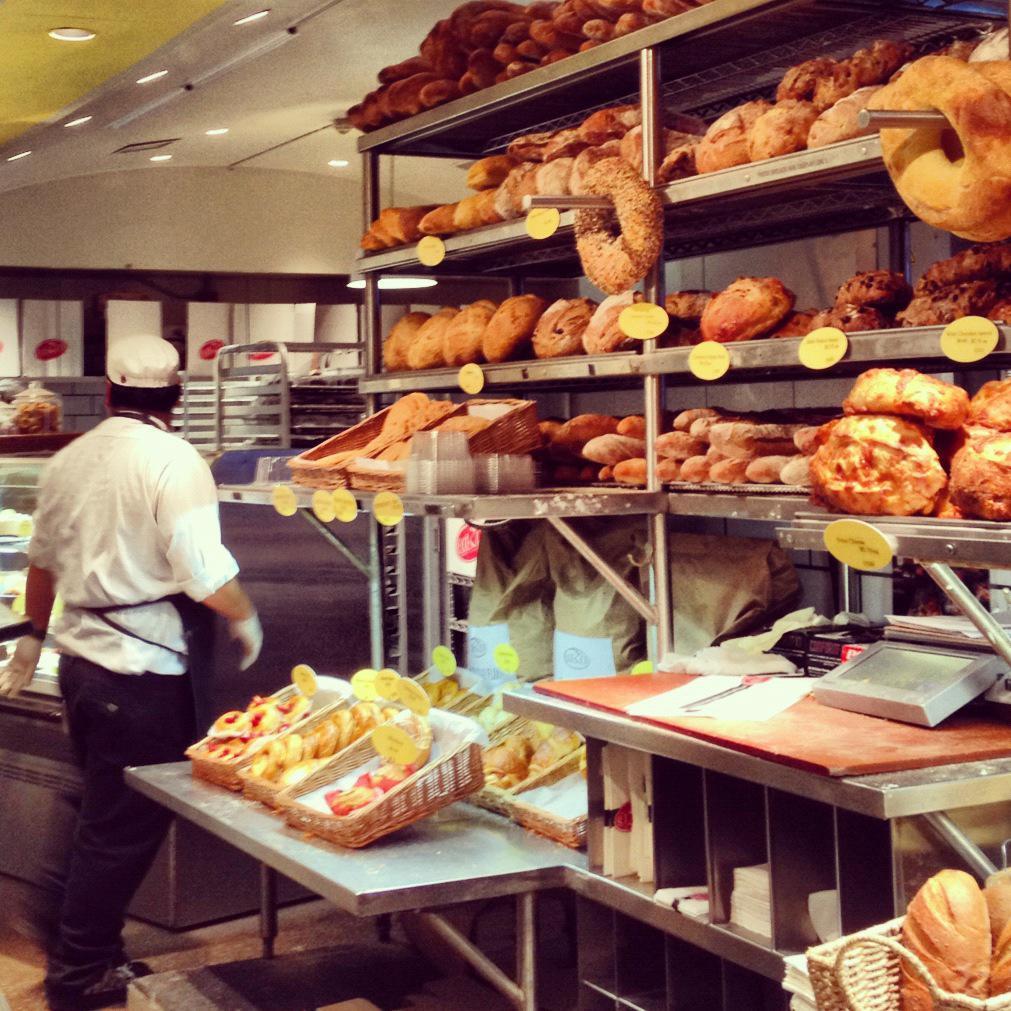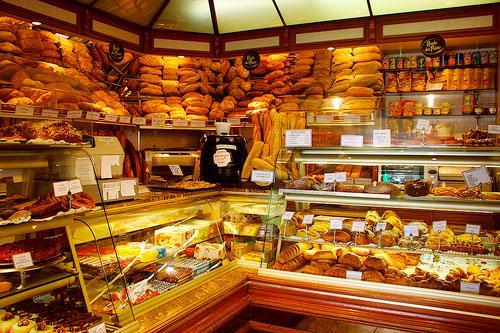The first image is the image on the left, the second image is the image on the right. Examine the images to the left and right. Is the description "A black chalkboard advertises items next to a food display in one bakery." accurate? Answer yes or no. No. 